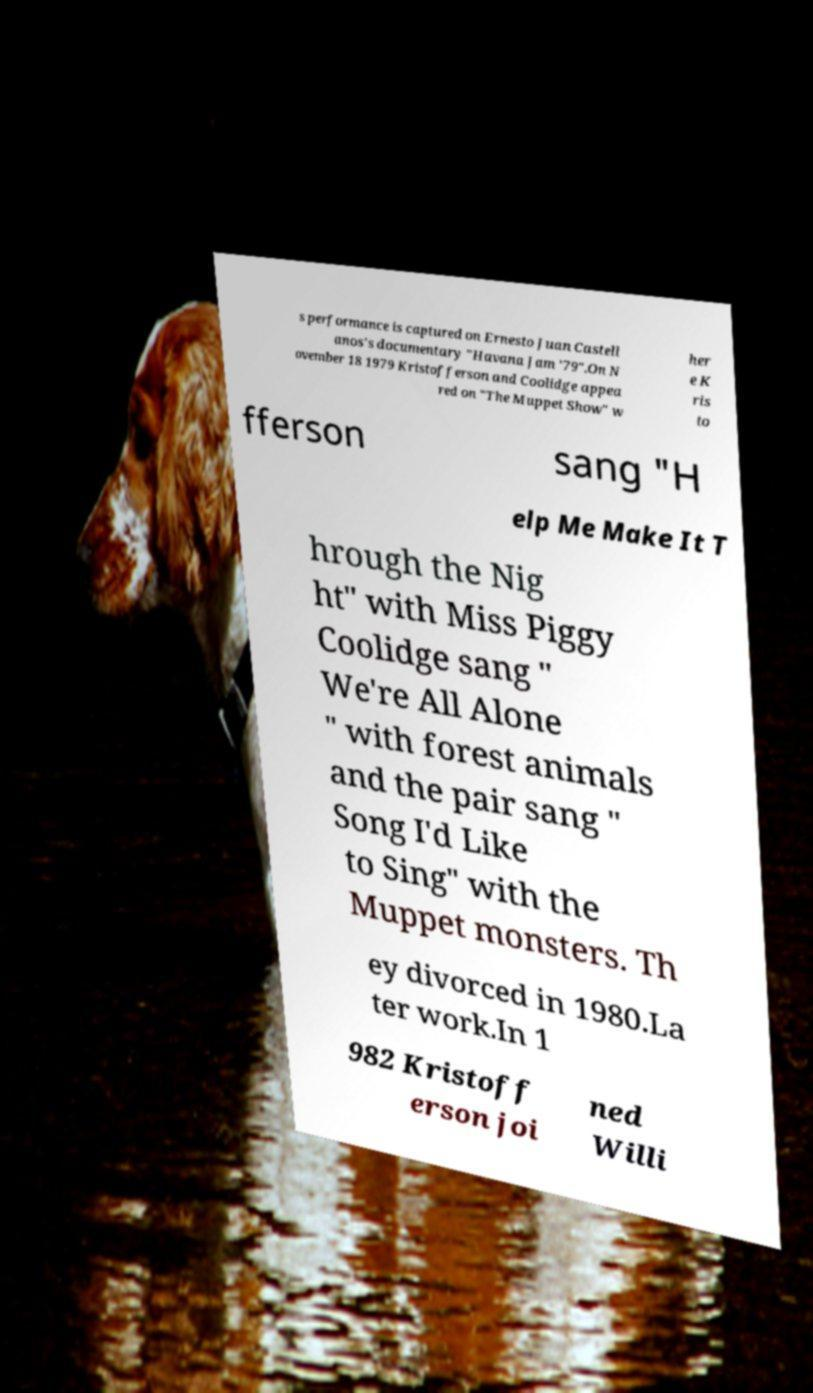For documentation purposes, I need the text within this image transcribed. Could you provide that? s performance is captured on Ernesto Juan Castell anos's documentary "Havana Jam '79".On N ovember 18 1979 Kristofferson and Coolidge appea red on "The Muppet Show" w her e K ris to fferson sang "H elp Me Make It T hrough the Nig ht" with Miss Piggy Coolidge sang " We're All Alone " with forest animals and the pair sang " Song I'd Like to Sing" with the Muppet monsters. Th ey divorced in 1980.La ter work.In 1 982 Kristoff erson joi ned Willi 